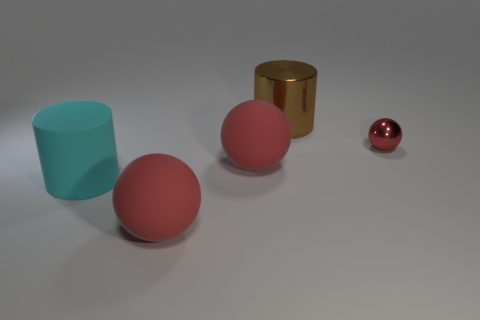Are there any other things that have the same size as the red shiny ball?
Your answer should be very brief. No. How many other objects are the same size as the brown cylinder?
Your answer should be compact. 3. How many objects are either red spheres that are on the left side of the red metal object or red balls left of the small metallic sphere?
Provide a short and direct response. 2. Is the cyan cylinder made of the same material as the sphere that is on the right side of the large brown metallic cylinder?
Ensure brevity in your answer.  No. How many other objects are the same shape as the big brown object?
Ensure brevity in your answer.  1. What is the ball in front of the rubber thing behind the big rubber cylinder in front of the big brown shiny thing made of?
Provide a short and direct response. Rubber. Are there an equal number of large red rubber spheres left of the tiny red object and tiny purple blocks?
Your answer should be compact. No. Is the large cylinder that is behind the tiny red shiny ball made of the same material as the ball on the right side of the large brown metal object?
Ensure brevity in your answer.  Yes. Are there any other things that are made of the same material as the large cyan thing?
Keep it short and to the point. Yes. Does the big object in front of the large cyan rubber cylinder have the same shape as the shiny thing that is in front of the large brown metal cylinder?
Your response must be concise. Yes. 